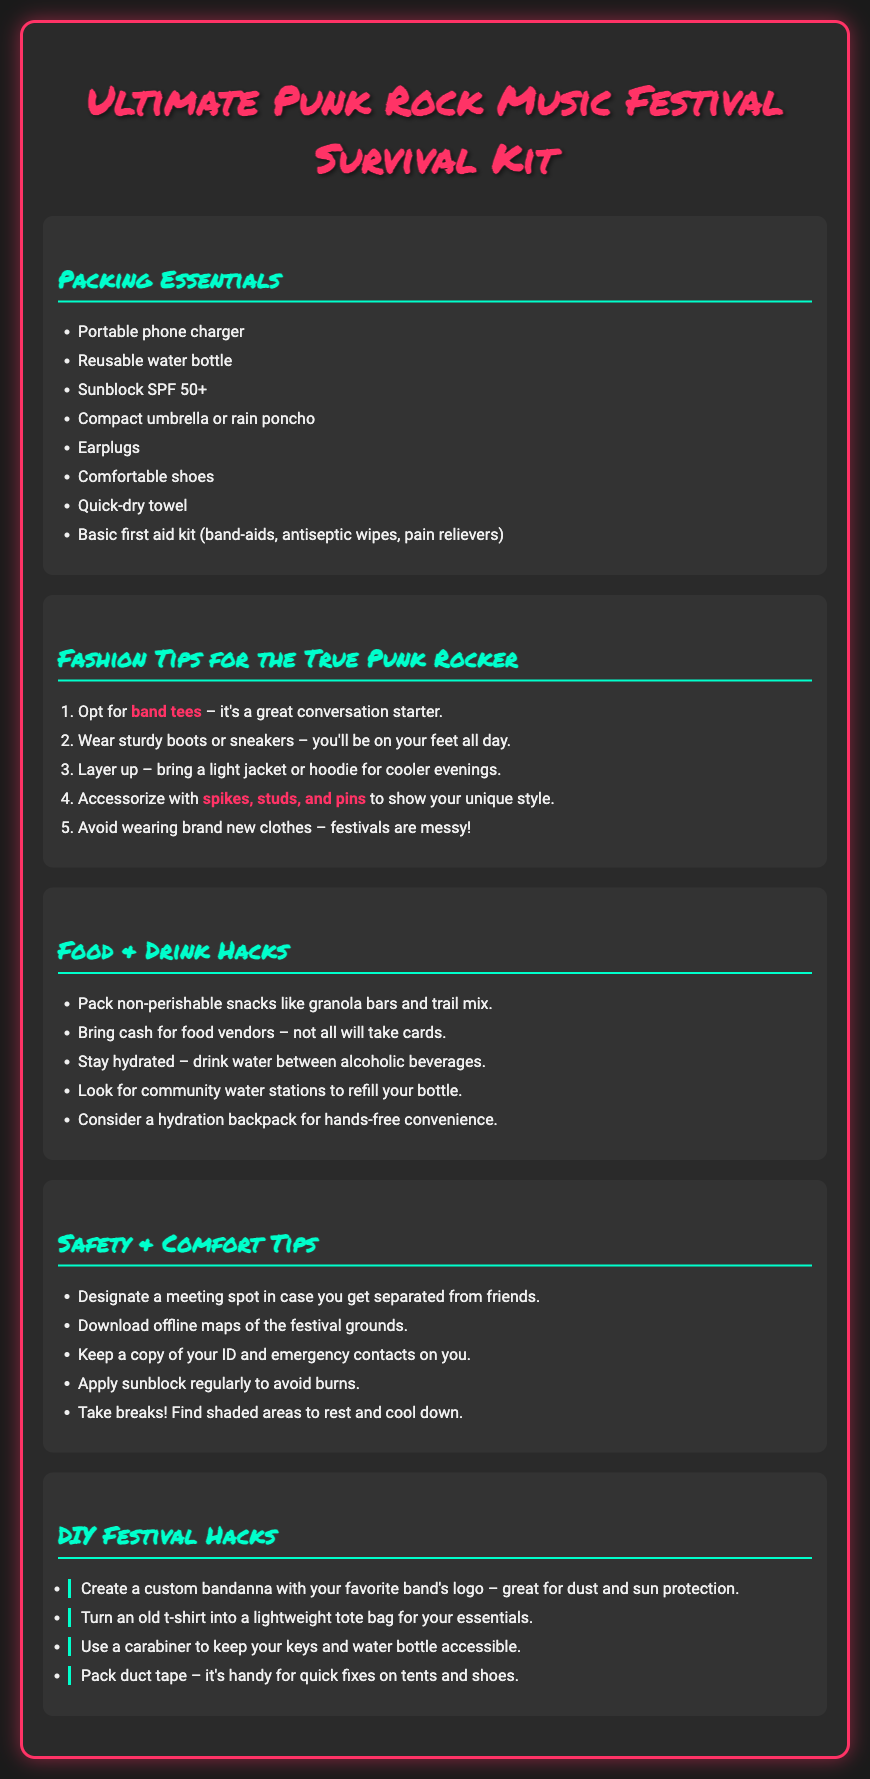What is the title of the document? The title of the document, as mentioned at the top, is "Ultimate Punk Rock Music Festival Survival Kit."
Answer: Ultimate Punk Rock Music Festival Survival Kit How many packing essential items are listed? There are eight packing essential items listed in the document.
Answer: 8 What is a recommended fashion tip for a punk rocker? One of the fashion tips mentioned is to wear sturdy boots or sneakers.
Answer: Sturdy boots or sneakers What should you use a carabiner for? A carabiner is suggested to keep your keys and water bottle accessible.
Answer: Keys and water bottle Which item is suggested for hydration convenience? A hydration backpack is recommended for hands-free convenience.
Answer: Hydration backpack What is one way to customize a bandanna? You can create a custom bandanna with your favorite band's logo.
Answer: Favorite band's logo How many safety tips are provided in the document? There are five safety tips provided in the document.
Answer: 5 What essential item should you pack to avoid sunburn? Sunblock SPF 50+ is essential to avoid sunburn.
Answer: Sunblock SPF 50+ What is suggested for comfortable feet during the festival? Comfortable shoes are suggested for being on your feet all day.
Answer: Comfortable shoes 